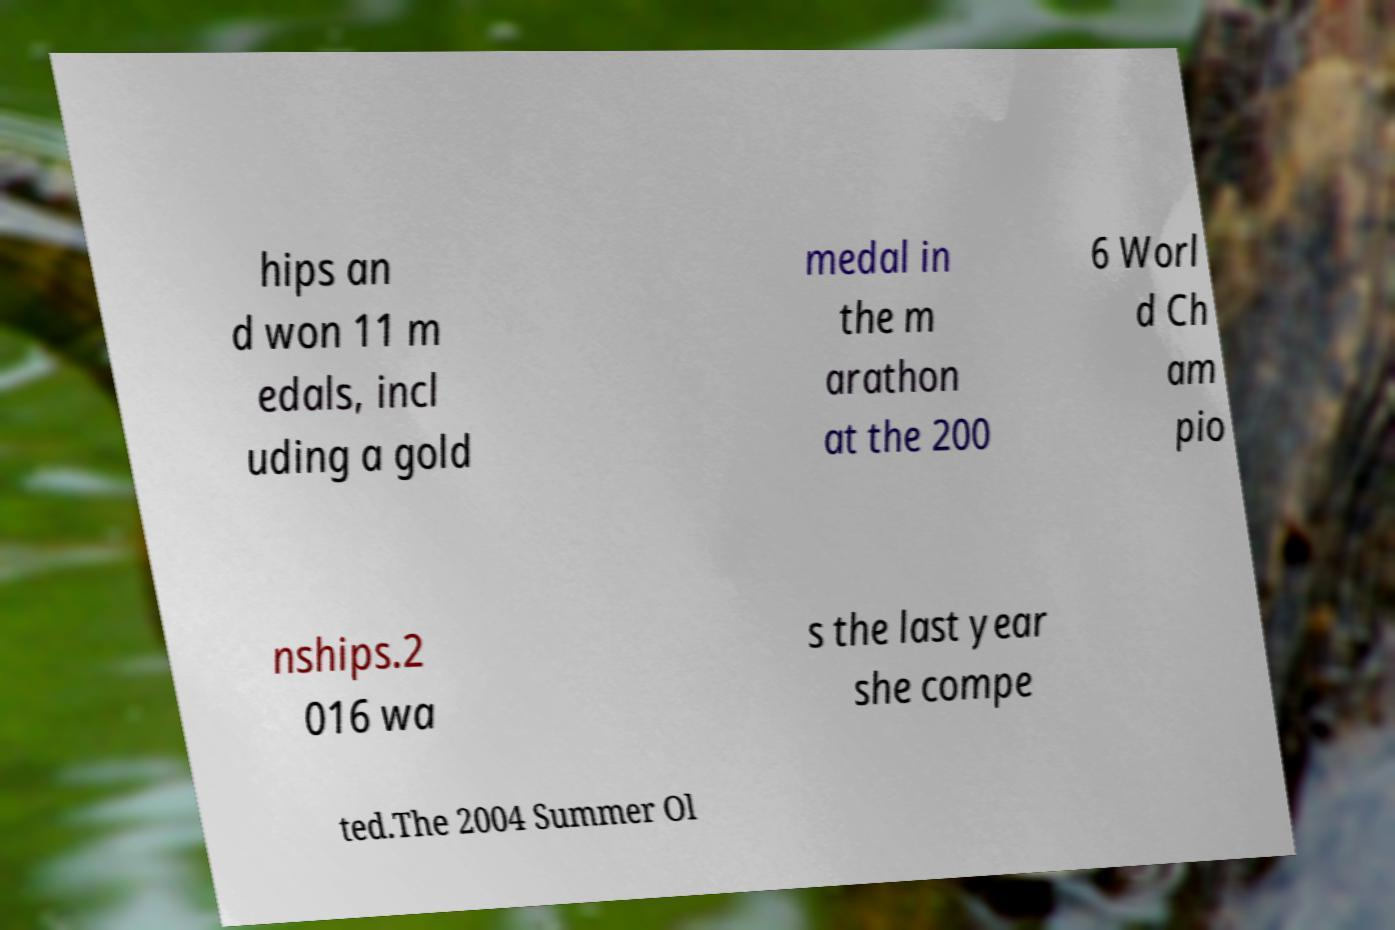Can you accurately transcribe the text from the provided image for me? hips an d won 11 m edals, incl uding a gold medal in the m arathon at the 200 6 Worl d Ch am pio nships.2 016 wa s the last year she compe ted.The 2004 Summer Ol 